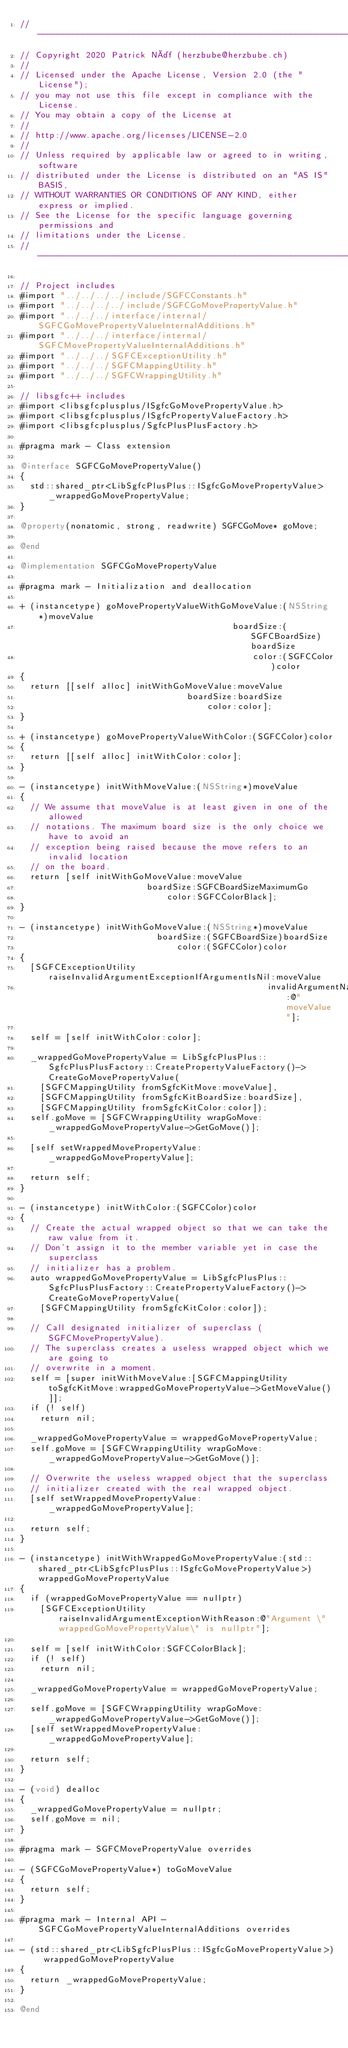<code> <loc_0><loc_0><loc_500><loc_500><_ObjectiveC_>// -----------------------------------------------------------------------------
// Copyright 2020 Patrick Näf (herzbube@herzbube.ch)
//
// Licensed under the Apache License, Version 2.0 (the "License");
// you may not use this file except in compliance with the License.
// You may obtain a copy of the License at
//
// http://www.apache.org/licenses/LICENSE-2.0
//
// Unless required by applicable law or agreed to in writing, software
// distributed under the License is distributed on an "AS IS" BASIS,
// WITHOUT WARRANTIES OR CONDITIONS OF ANY KIND, either express or implied.
// See the License for the specific language governing permissions and
// limitations under the License.
// -----------------------------------------------------------------------------

// Project includes
#import "../../../../include/SGFCConstants.h"
#import "../../../../include/SGFCGoMovePropertyValue.h"
#import "../../../interface/internal/SGFCGoMovePropertyValueInternalAdditions.h"
#import "../../../interface/internal/SGFCMovePropertyValueInternalAdditions.h"
#import "../../../SGFCExceptionUtility.h"
#import "../../../SGFCMappingUtility.h"
#import "../../../SGFCWrappingUtility.h"

// libsgfc++ includes
#import <libsgfcplusplus/ISgfcGoMovePropertyValue.h>
#import <libsgfcplusplus/ISgfcPropertyValueFactory.h>
#import <libsgfcplusplus/SgfcPlusPlusFactory.h>

#pragma mark - Class extension

@interface SGFCGoMovePropertyValue()
{
  std::shared_ptr<LibSgfcPlusPlus::ISgfcGoMovePropertyValue> _wrappedGoMovePropertyValue;
}

@property(nonatomic, strong, readwrite) SGFCGoMove* goMove;

@end

@implementation SGFCGoMovePropertyValue

#pragma mark - Initialization and deallocation

+ (instancetype) goMovePropertyValueWithGoMoveValue:(NSString*)moveValue
                                          boardSize:(SGFCBoardSize)boardSize
                                              color:(SGFCColor)color
{
  return [[self alloc] initWithGoMoveValue:moveValue
                                 boardSize:boardSize
                                     color:color];
}

+ (instancetype) goMovePropertyValueWithColor:(SGFCColor)color
{
  return [[self alloc] initWithColor:color];
}

- (instancetype) initWithMoveValue:(NSString*)moveValue
{
  // We assume that moveValue is at least given in one of the allowed
  // notations. The maximum board size is the only choice we have to avoid an
  // exception being raised because the move refers to an invalid location
  // on the board.
  return [self initWithGoMoveValue:moveValue
                         boardSize:SGFCBoardSizeMaximumGo
                             color:SGFCColorBlack];
}

- (instancetype) initWithGoMoveValue:(NSString*)moveValue
                           boardSize:(SGFCBoardSize)boardSize
                               color:(SGFCColor)color
{
  [SGFCExceptionUtility raiseInvalidArgumentExceptionIfArgumentIsNil:moveValue
                                                 invalidArgumentName:@"moveValue"];

  self = [self initWithColor:color];

  _wrappedGoMovePropertyValue = LibSgfcPlusPlus::SgfcPlusPlusFactory::CreatePropertyValueFactory()->CreateGoMovePropertyValue(
    [SGFCMappingUtility fromSgfcKitMove:moveValue],
    [SGFCMappingUtility fromSgfcKitBoardSize:boardSize],
    [SGFCMappingUtility fromSgfcKitColor:color]);
  self.goMove = [SGFCWrappingUtility wrapGoMove:_wrappedGoMovePropertyValue->GetGoMove()];

  [self setWrappedMovePropertyValue:_wrappedGoMovePropertyValue];

  return self;
}

- (instancetype) initWithColor:(SGFCColor)color
{
  // Create the actual wrapped object so that we can take the raw value from it.
  // Don't assign it to the member variable yet in case the superclass
  // initializer has a problem.
  auto wrappedGoMovePropertyValue = LibSgfcPlusPlus::SgfcPlusPlusFactory::CreatePropertyValueFactory()->CreateGoMovePropertyValue(
    [SGFCMappingUtility fromSgfcKitColor:color]);

  // Call designated initializer of superclass (SGFCMovePropertyValue).
  // The superclass creates a useless wrapped object which we are going to
  // overwrite in a moment.
  self = [super initWithMoveValue:[SGFCMappingUtility toSgfcKitMove:wrappedGoMovePropertyValue->GetMoveValue()]];
  if (! self)
    return nil;

  _wrappedGoMovePropertyValue = wrappedGoMovePropertyValue;
  self.goMove = [SGFCWrappingUtility wrapGoMove:_wrappedGoMovePropertyValue->GetGoMove()];

  // Overwrite the useless wrapped object that the superclass
  // initializer created with the real wrapped object.
  [self setWrappedMovePropertyValue:_wrappedGoMovePropertyValue];

  return self;
}

- (instancetype) initWithWrappedGoMovePropertyValue:(std::shared_ptr<LibSgfcPlusPlus::ISgfcGoMovePropertyValue>)wrappedGoMovePropertyValue
{
  if (wrappedGoMovePropertyValue == nullptr)
    [SGFCExceptionUtility raiseInvalidArgumentExceptionWithReason:@"Argument \"wrappedGoMovePropertyValue\" is nullptr"];

  self = [self initWithColor:SGFCColorBlack];
  if (! self)
    return nil;

  _wrappedGoMovePropertyValue = wrappedGoMovePropertyValue;

  self.goMove = [SGFCWrappingUtility wrapGoMove:_wrappedGoMovePropertyValue->GetGoMove()];
  [self setWrappedMovePropertyValue:_wrappedGoMovePropertyValue];

  return self;
}

- (void) dealloc
{
  _wrappedGoMovePropertyValue = nullptr;
  self.goMove = nil;
}

#pragma mark - SGFCMovePropertyValue overrides

- (SGFCGoMovePropertyValue*) toGoMoveValue
{
  return self;
}

#pragma mark - Internal API - SGFCGoMovePropertyValueInternalAdditions overrides

- (std::shared_ptr<LibSgfcPlusPlus::ISgfcGoMovePropertyValue>) wrappedGoMovePropertyValue
{
  return _wrappedGoMovePropertyValue;
}

@end
</code> 